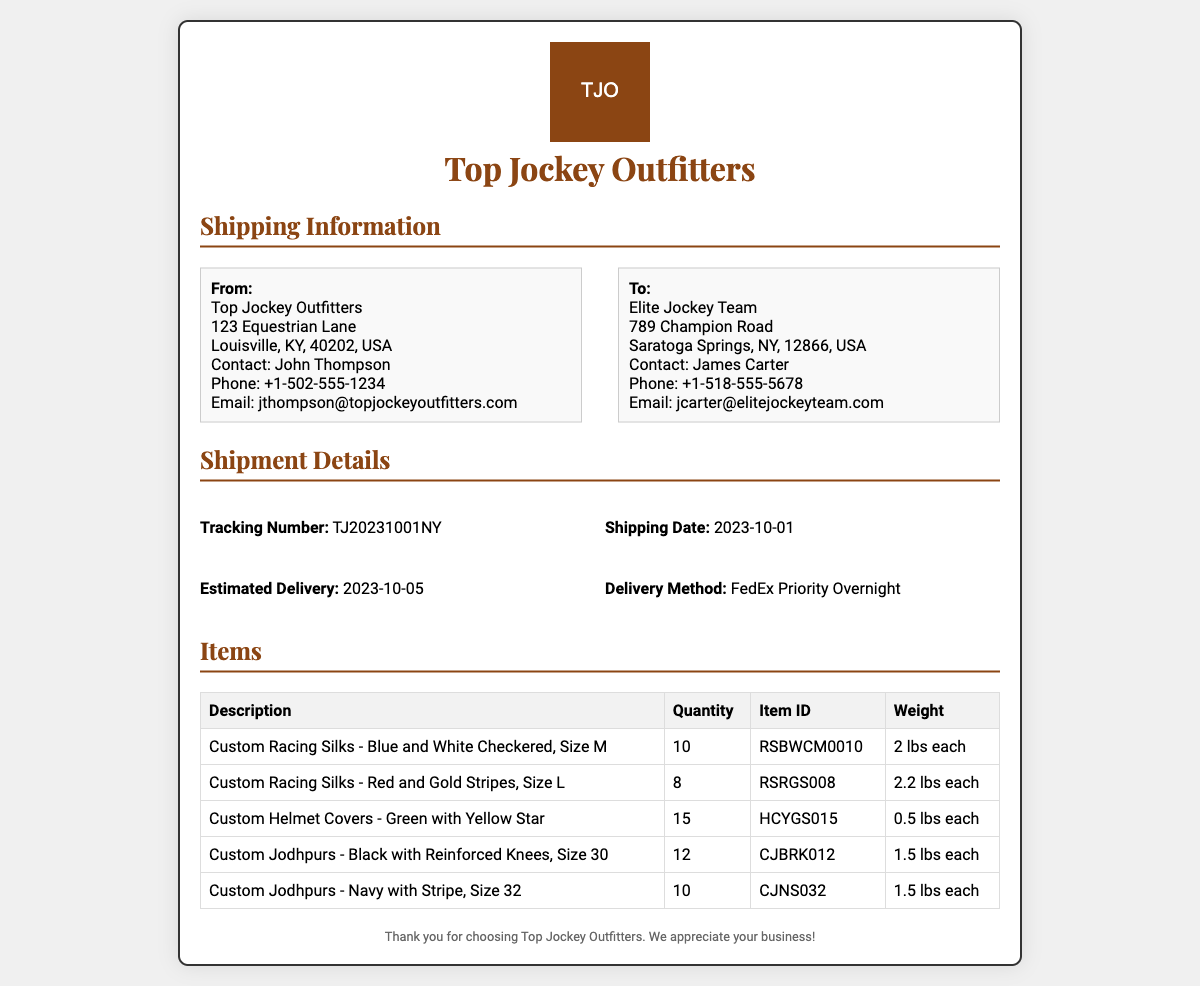what is the shipping date? The shipping date is provided in the "Shipment Details" section of the document, indicating when the items were shipped.
Answer: 2023-10-01 who is the contact at the sender's address? The sender's address includes the name of the person to contact for more information.
Answer: John Thompson what is the total quantity of Custom Racing Silks ordered? The total quantity can be derived from the itemized list of Custom Racing Silks in the document.
Answer: 10 what is the weight of each Custom Helmet Cover? The weight of each Custom Helmet Cover is specified in the item details within the document.
Answer: 0.5 lbs each what is the tracking number for this shipment? The tracking number is a key detail found in the shipment information.
Answer: TJ20231001NY how many different types of items are listed? The number of different types of items is counted from the items listed in the document.
Answer: 5 what is the estimated delivery date? The estimated delivery date is provided in the "Shipment Details" section and indicates when the items are expected to arrive.
Answer: 2023-10-05 what is the delivery method used for this shipment? The delivery method used is detailed in the shipment information section of the document.
Answer: FedEx Priority Overnight what is the name of the recipient's organization? The name of the organization receiving the shipment is clearly stated in the address section of the document.
Answer: Elite Jockey Team 